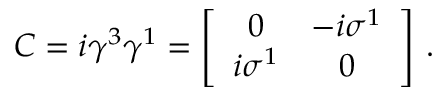<formula> <loc_0><loc_0><loc_500><loc_500>C = i \gamma ^ { 3 } \gamma ^ { 1 } = \left [ \begin{array} { c c } { 0 } & { { - i \sigma ^ { 1 } } } \\ { { i \sigma ^ { 1 } } } & { 0 } \end{array} \right ] \, .</formula> 